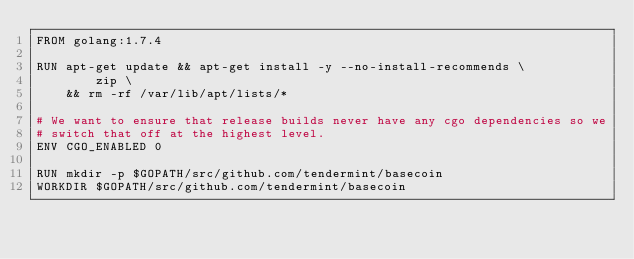<code> <loc_0><loc_0><loc_500><loc_500><_Dockerfile_>FROM golang:1.7.4

RUN apt-get update && apt-get install -y --no-install-recommends \
		zip \
	&& rm -rf /var/lib/apt/lists/*

# We want to ensure that release builds never have any cgo dependencies so we
# switch that off at the highest level.
ENV CGO_ENABLED 0

RUN mkdir -p $GOPATH/src/github.com/tendermint/basecoin
WORKDIR $GOPATH/src/github.com/tendermint/basecoin
</code> 